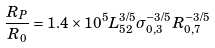Convert formula to latex. <formula><loc_0><loc_0><loc_500><loc_500>\frac { R _ { P } } { R _ { 0 } } = 1 . 4 \times 1 0 ^ { 5 } L _ { 5 2 } ^ { 3 / 5 } \sigma _ { 0 , 3 } ^ { - 3 / 5 } R _ { 0 , 7 } ^ { - 3 / 5 }</formula> 